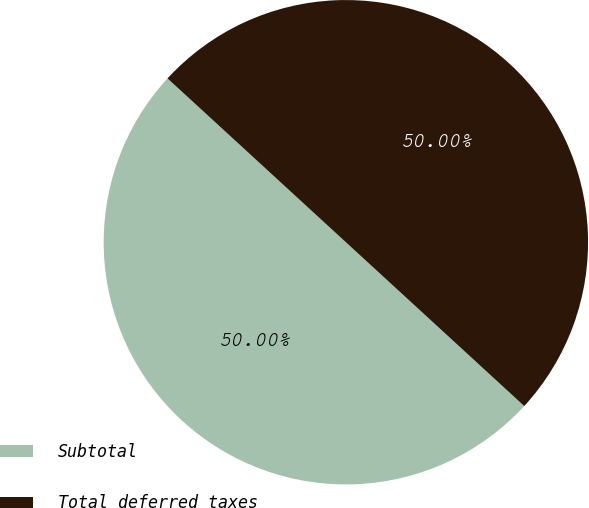Convert chart. <chart><loc_0><loc_0><loc_500><loc_500><pie_chart><fcel>Subtotal<fcel>Total deferred taxes<nl><fcel>50.0%<fcel>50.0%<nl></chart> 